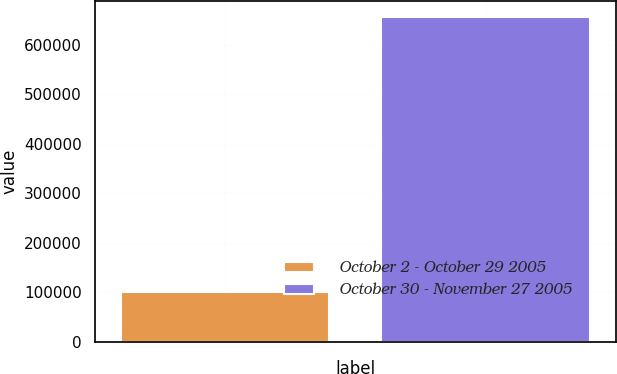<chart> <loc_0><loc_0><loc_500><loc_500><bar_chart><fcel>October 2 - October 29 2005<fcel>October 30 - November 27 2005<nl><fcel>100000<fcel>655663<nl></chart> 